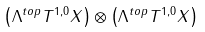<formula> <loc_0><loc_0><loc_500><loc_500>\left ( \Lambda ^ { t o p } T ^ { 1 , 0 } X \right ) \otimes \left ( \Lambda ^ { t o p } T ^ { 1 , 0 } X \right )</formula> 